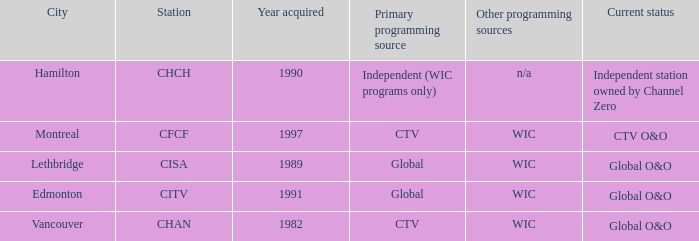Would you mind parsing the complete table? {'header': ['City', 'Station', 'Year acquired', 'Primary programming source', 'Other programming sources', 'Current status'], 'rows': [['Hamilton', 'CHCH', '1990', 'Independent (WIC programs only)', 'n/a', 'Independent station owned by Channel Zero'], ['Montreal', 'CFCF', '1997', 'CTV', 'WIC', 'CTV O&O'], ['Lethbridge', 'CISA', '1989', 'Global', 'WIC', 'Global O&O'], ['Edmonton', 'CITV', '1991', 'Global', 'WIC', 'Global O&O'], ['Vancouver', 'CHAN', '1982', 'CTV', 'WIC', 'Global O&O']]} Where is citv located Edmonton. 